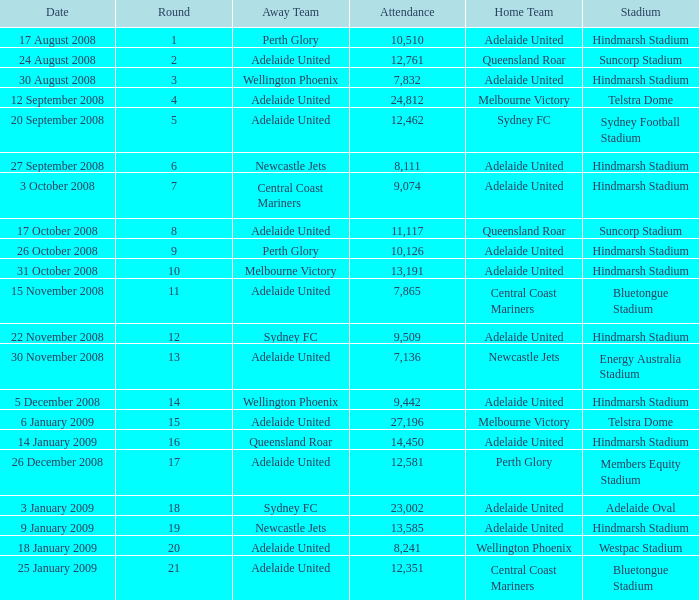Who was the away team when Queensland Roar was the home team in the round less than 3? Adelaide United. 